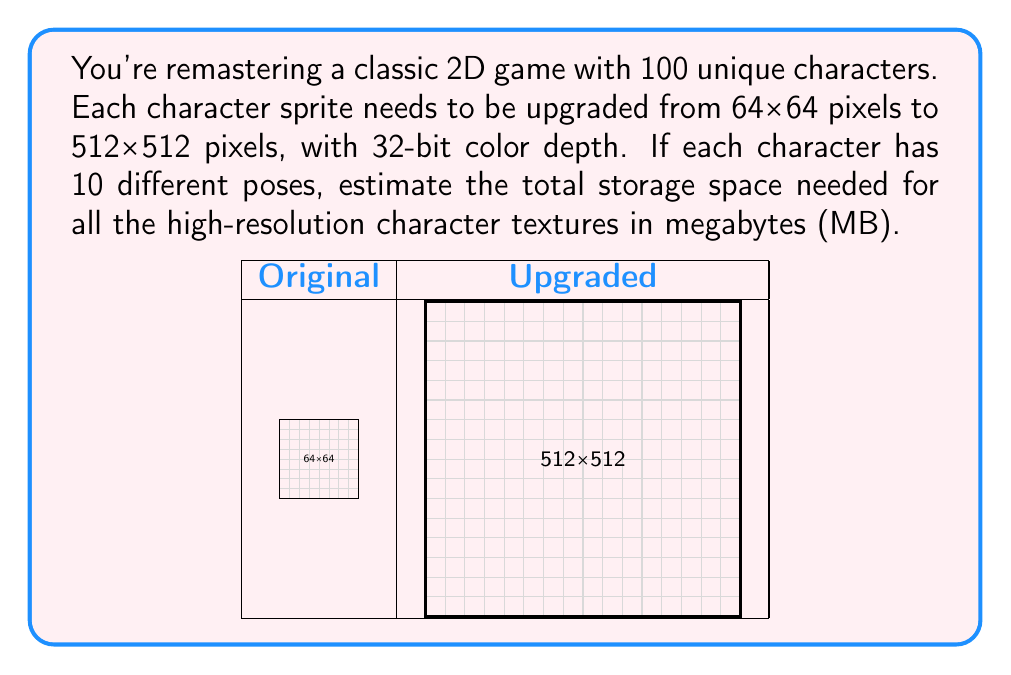Could you help me with this problem? Let's break this down step-by-step:

1) First, calculate the number of pixels in each high-resolution sprite:
   $512 \times 512 = 262,144$ pixels

2) Each pixel uses 32-bit color depth, which is equivalent to 4 bytes:
   $32 \text{ bits} = 4 \text{ bytes}$

3) Calculate the size of one sprite in bytes:
   $262,144 \text{ pixels} \times 4 \text{ bytes/pixel} = 1,048,576 \text{ bytes}$

4) Each character has 10 poses, so multiply by 10:
   $1,048,576 \text{ bytes} \times 10 = 10,485,760 \text{ bytes per character}$

5) There are 100 unique characters, so multiply by 100:
   $10,485,760 \text{ bytes} \times 100 = 1,048,576,000 \text{ bytes total}$

6) Convert bytes to megabytes:
   $$\frac{1,048,576,000 \text{ bytes}}{1,048,576 \text{ bytes/MB}} = 1,000 \text{ MB}$$

Therefore, the total storage space needed is 1,000 MB or 1 GB.
Answer: 1,000 MB 